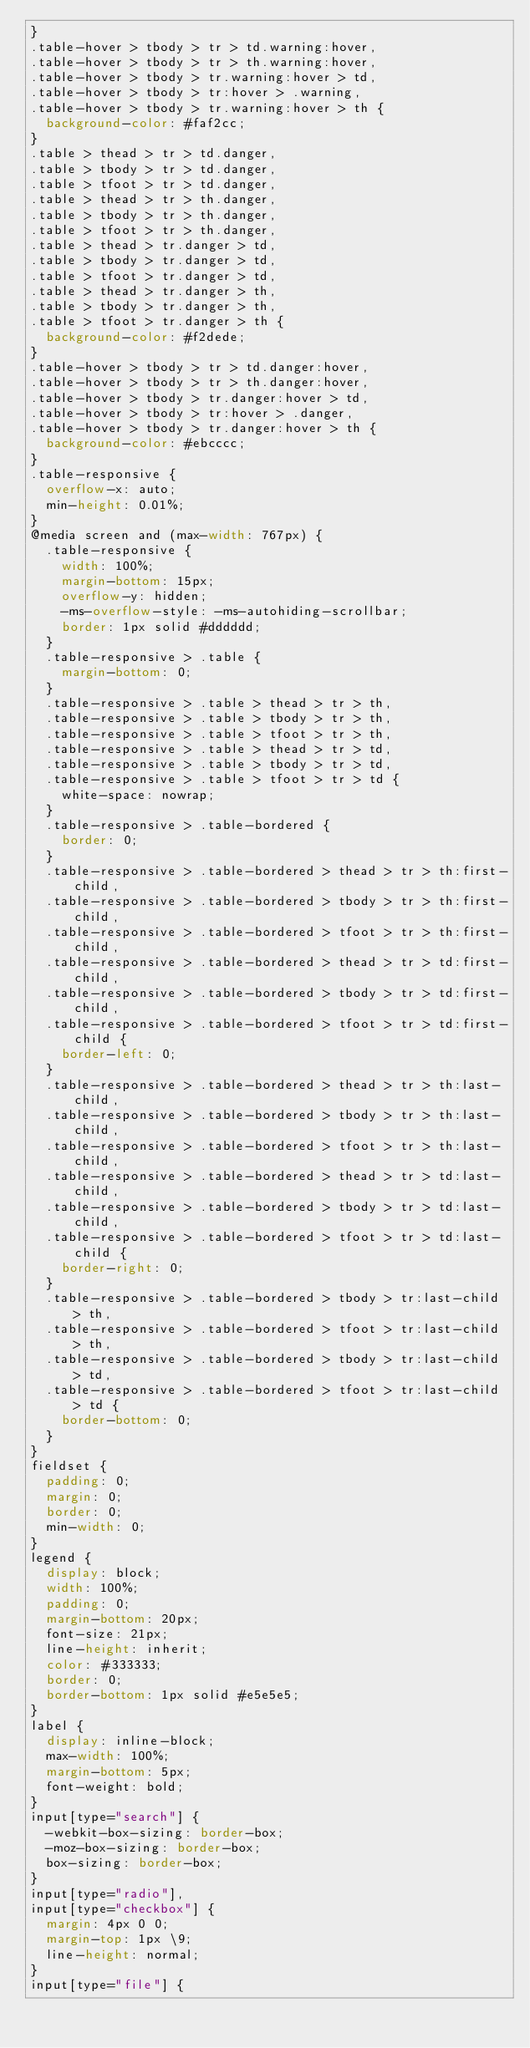Convert code to text. <code><loc_0><loc_0><loc_500><loc_500><_CSS_>}
.table-hover > tbody > tr > td.warning:hover,
.table-hover > tbody > tr > th.warning:hover,
.table-hover > tbody > tr.warning:hover > td,
.table-hover > tbody > tr:hover > .warning,
.table-hover > tbody > tr.warning:hover > th {
  background-color: #faf2cc;
}
.table > thead > tr > td.danger,
.table > tbody > tr > td.danger,
.table > tfoot > tr > td.danger,
.table > thead > tr > th.danger,
.table > tbody > tr > th.danger,
.table > tfoot > tr > th.danger,
.table > thead > tr.danger > td,
.table > tbody > tr.danger > td,
.table > tfoot > tr.danger > td,
.table > thead > tr.danger > th,
.table > tbody > tr.danger > th,
.table > tfoot > tr.danger > th {
  background-color: #f2dede;
}
.table-hover > tbody > tr > td.danger:hover,
.table-hover > tbody > tr > th.danger:hover,
.table-hover > tbody > tr.danger:hover > td,
.table-hover > tbody > tr:hover > .danger,
.table-hover > tbody > tr.danger:hover > th {
  background-color: #ebcccc;
}
.table-responsive {
  overflow-x: auto;
  min-height: 0.01%;
}
@media screen and (max-width: 767px) {
  .table-responsive {
    width: 100%;
    margin-bottom: 15px;
    overflow-y: hidden;
    -ms-overflow-style: -ms-autohiding-scrollbar;
    border: 1px solid #dddddd;
  }
  .table-responsive > .table {
    margin-bottom: 0;
  }
  .table-responsive > .table > thead > tr > th,
  .table-responsive > .table > tbody > tr > th,
  .table-responsive > .table > tfoot > tr > th,
  .table-responsive > .table > thead > tr > td,
  .table-responsive > .table > tbody > tr > td,
  .table-responsive > .table > tfoot > tr > td {
    white-space: nowrap;
  }
  .table-responsive > .table-bordered {
    border: 0;
  }
  .table-responsive > .table-bordered > thead > tr > th:first-child,
  .table-responsive > .table-bordered > tbody > tr > th:first-child,
  .table-responsive > .table-bordered > tfoot > tr > th:first-child,
  .table-responsive > .table-bordered > thead > tr > td:first-child,
  .table-responsive > .table-bordered > tbody > tr > td:first-child,
  .table-responsive > .table-bordered > tfoot > tr > td:first-child {
    border-left: 0;
  }
  .table-responsive > .table-bordered > thead > tr > th:last-child,
  .table-responsive > .table-bordered > tbody > tr > th:last-child,
  .table-responsive > .table-bordered > tfoot > tr > th:last-child,
  .table-responsive > .table-bordered > thead > tr > td:last-child,
  .table-responsive > .table-bordered > tbody > tr > td:last-child,
  .table-responsive > .table-bordered > tfoot > tr > td:last-child {
    border-right: 0;
  }
  .table-responsive > .table-bordered > tbody > tr:last-child > th,
  .table-responsive > .table-bordered > tfoot > tr:last-child > th,
  .table-responsive > .table-bordered > tbody > tr:last-child > td,
  .table-responsive > .table-bordered > tfoot > tr:last-child > td {
    border-bottom: 0;
  }
}
fieldset {
  padding: 0;
  margin: 0;
  border: 0;
  min-width: 0;
}
legend {
  display: block;
  width: 100%;
  padding: 0;
  margin-bottom: 20px;
  font-size: 21px;
  line-height: inherit;
  color: #333333;
  border: 0;
  border-bottom: 1px solid #e5e5e5;
}
label {
  display: inline-block;
  max-width: 100%;
  margin-bottom: 5px;
  font-weight: bold;
}
input[type="search"] {
  -webkit-box-sizing: border-box;
  -moz-box-sizing: border-box;
  box-sizing: border-box;
}
input[type="radio"],
input[type="checkbox"] {
  margin: 4px 0 0;
  margin-top: 1px \9;
  line-height: normal;
}
input[type="file"] {</code> 